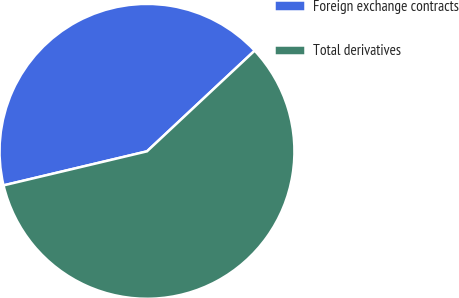Convert chart. <chart><loc_0><loc_0><loc_500><loc_500><pie_chart><fcel>Foreign exchange contracts<fcel>Total derivatives<nl><fcel>41.74%<fcel>58.26%<nl></chart> 